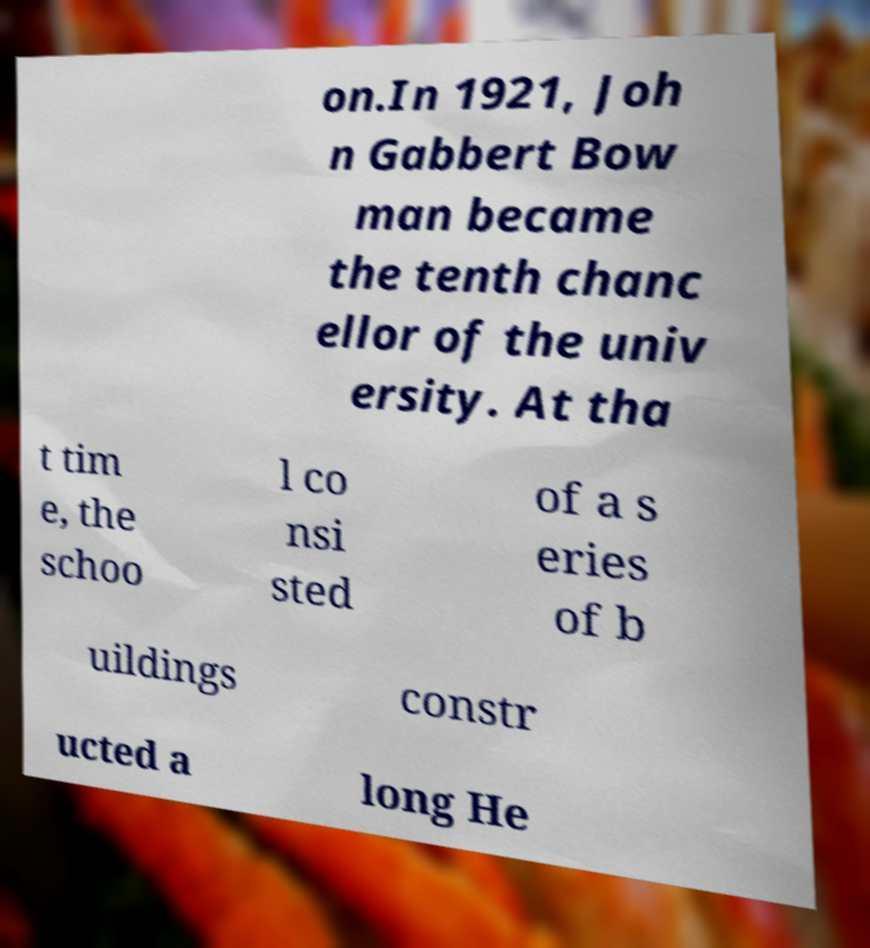Could you assist in decoding the text presented in this image and type it out clearly? on.In 1921, Joh n Gabbert Bow man became the tenth chanc ellor of the univ ersity. At tha t tim e, the schoo l co nsi sted of a s eries of b uildings constr ucted a long He 